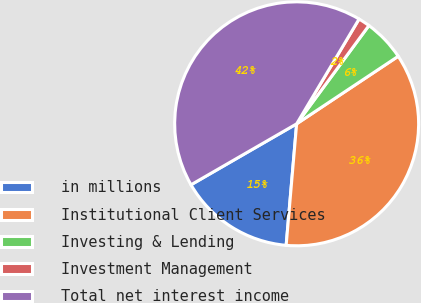Convert chart. <chart><loc_0><loc_0><loc_500><loc_500><pie_chart><fcel>in millions<fcel>Institutional Client Services<fcel>Investing & Lending<fcel>Investment Management<fcel>Total net interest income<nl><fcel>15.3%<fcel>35.71%<fcel>5.57%<fcel>1.54%<fcel>41.88%<nl></chart> 